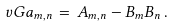Convert formula to latex. <formula><loc_0><loc_0><loc_500><loc_500>\ v G a _ { m , n } \, = \, A _ { m , n } - B _ { m } B _ { n } \, .</formula> 